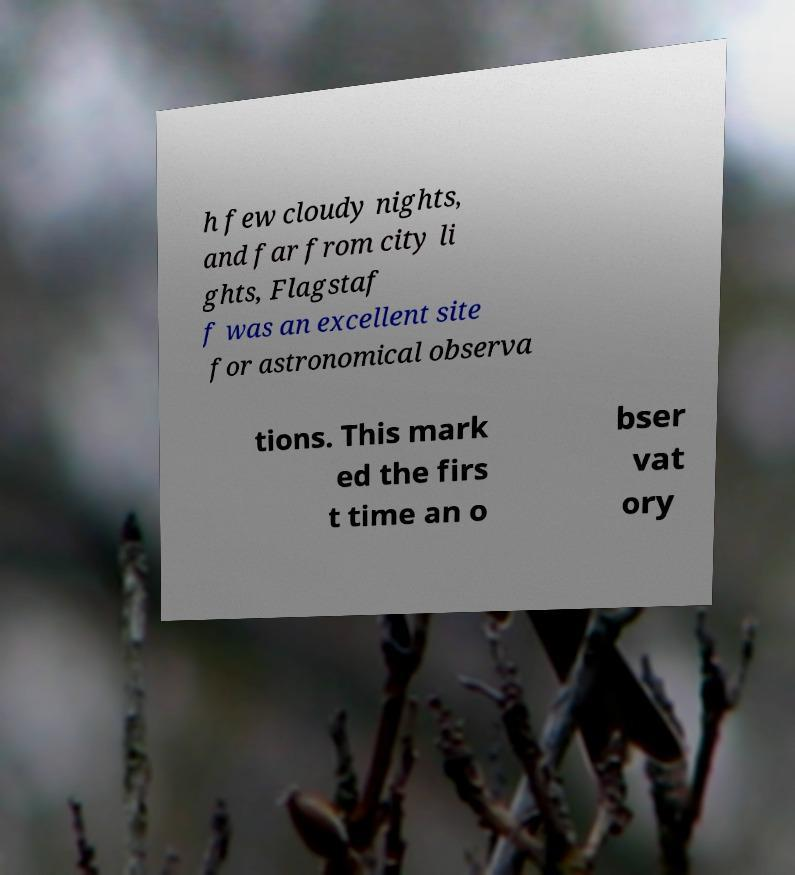Please read and relay the text visible in this image. What does it say? h few cloudy nights, and far from city li ghts, Flagstaf f was an excellent site for astronomical observa tions. This mark ed the firs t time an o bser vat ory 